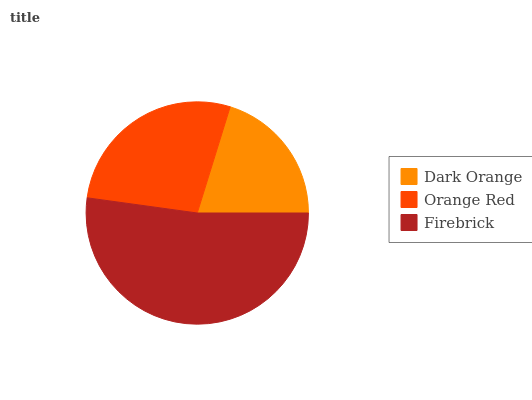Is Dark Orange the minimum?
Answer yes or no. Yes. Is Firebrick the maximum?
Answer yes or no. Yes. Is Orange Red the minimum?
Answer yes or no. No. Is Orange Red the maximum?
Answer yes or no. No. Is Orange Red greater than Dark Orange?
Answer yes or no. Yes. Is Dark Orange less than Orange Red?
Answer yes or no. Yes. Is Dark Orange greater than Orange Red?
Answer yes or no. No. Is Orange Red less than Dark Orange?
Answer yes or no. No. Is Orange Red the high median?
Answer yes or no. Yes. Is Orange Red the low median?
Answer yes or no. Yes. Is Dark Orange the high median?
Answer yes or no. No. Is Dark Orange the low median?
Answer yes or no. No. 